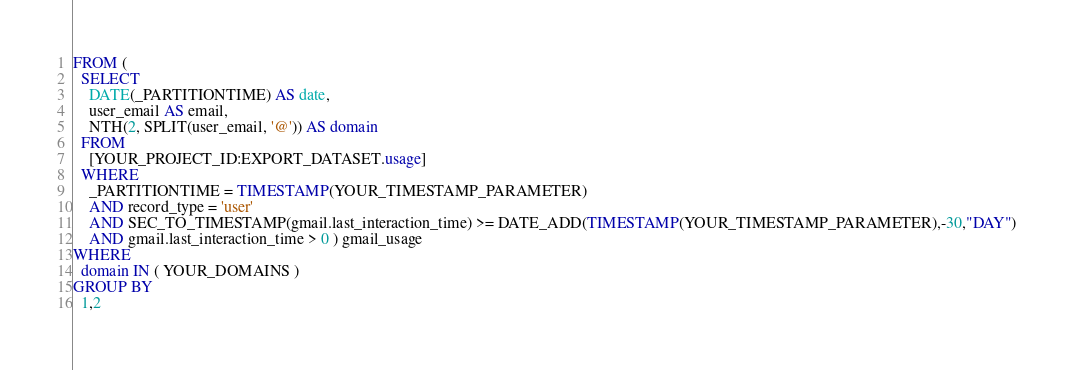Convert code to text. <code><loc_0><loc_0><loc_500><loc_500><_SQL_>FROM (
  SELECT
    DATE(_PARTITIONTIME) AS date,
    user_email AS email,
    NTH(2, SPLIT(user_email, '@')) AS domain
  FROM
    [YOUR_PROJECT_ID:EXPORT_DATASET.usage]
  WHERE
    _PARTITIONTIME = TIMESTAMP(YOUR_TIMESTAMP_PARAMETER)
    AND record_type = 'user'
    AND SEC_TO_TIMESTAMP(gmail.last_interaction_time) >= DATE_ADD(TIMESTAMP(YOUR_TIMESTAMP_PARAMETER),-30,"DAY")
    AND gmail.last_interaction_time > 0 ) gmail_usage
WHERE
  domain IN ( YOUR_DOMAINS )
GROUP BY
  1,2</code> 